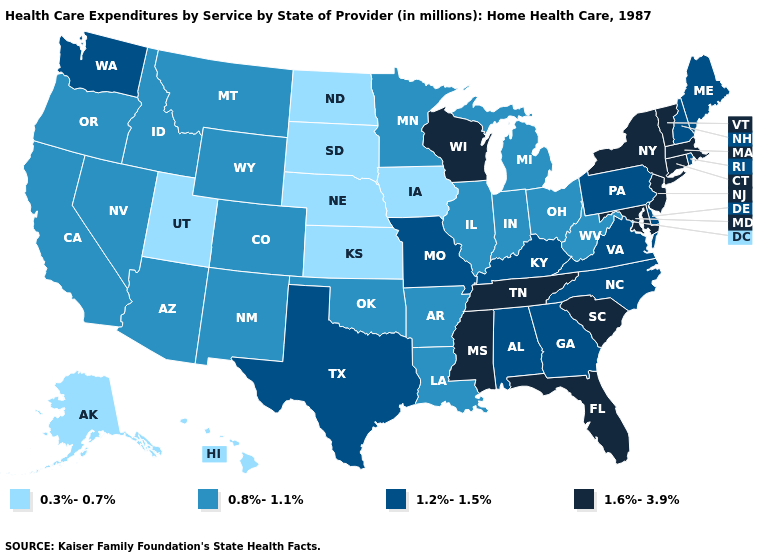What is the value of Connecticut?
Keep it brief. 1.6%-3.9%. Among the states that border Virginia , which have the highest value?
Short answer required. Maryland, Tennessee. Among the states that border North Dakota , does Minnesota have the highest value?
Quick response, please. Yes. Which states hav the highest value in the South?
Keep it brief. Florida, Maryland, Mississippi, South Carolina, Tennessee. Which states hav the highest value in the Northeast?
Short answer required. Connecticut, Massachusetts, New Jersey, New York, Vermont. What is the lowest value in the USA?
Answer briefly. 0.3%-0.7%. Does the first symbol in the legend represent the smallest category?
Short answer required. Yes. What is the value of Iowa?
Give a very brief answer. 0.3%-0.7%. What is the value of Oregon?
Concise answer only. 0.8%-1.1%. Does Wisconsin have a higher value than Indiana?
Keep it brief. Yes. Does New Jersey have the lowest value in the Northeast?
Keep it brief. No. Name the states that have a value in the range 1.6%-3.9%?
Keep it brief. Connecticut, Florida, Maryland, Massachusetts, Mississippi, New Jersey, New York, South Carolina, Tennessee, Vermont, Wisconsin. Among the states that border Louisiana , which have the lowest value?
Quick response, please. Arkansas. What is the lowest value in the West?
Concise answer only. 0.3%-0.7%. Which states have the lowest value in the USA?
Short answer required. Alaska, Hawaii, Iowa, Kansas, Nebraska, North Dakota, South Dakota, Utah. 